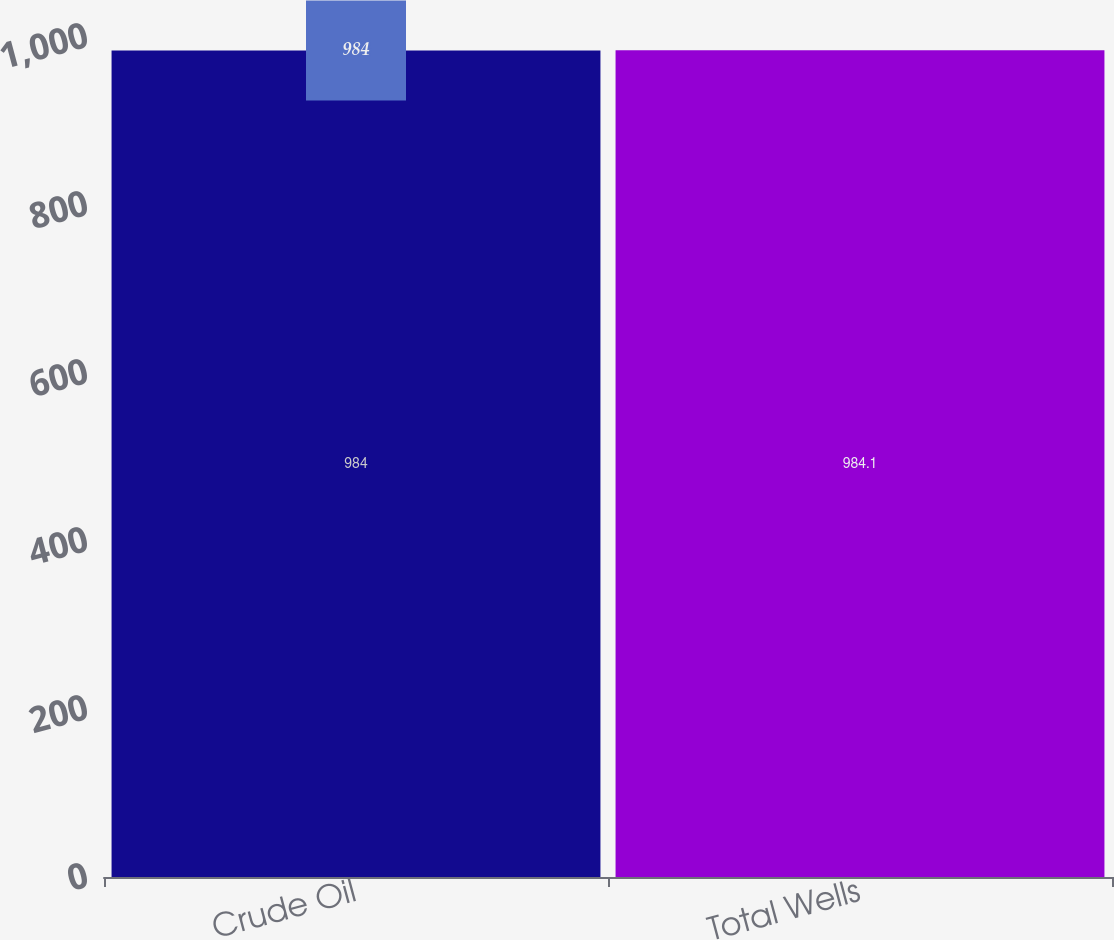Convert chart. <chart><loc_0><loc_0><loc_500><loc_500><bar_chart><fcel>Crude Oil<fcel>Total Wells<nl><fcel>984<fcel>984.1<nl></chart> 